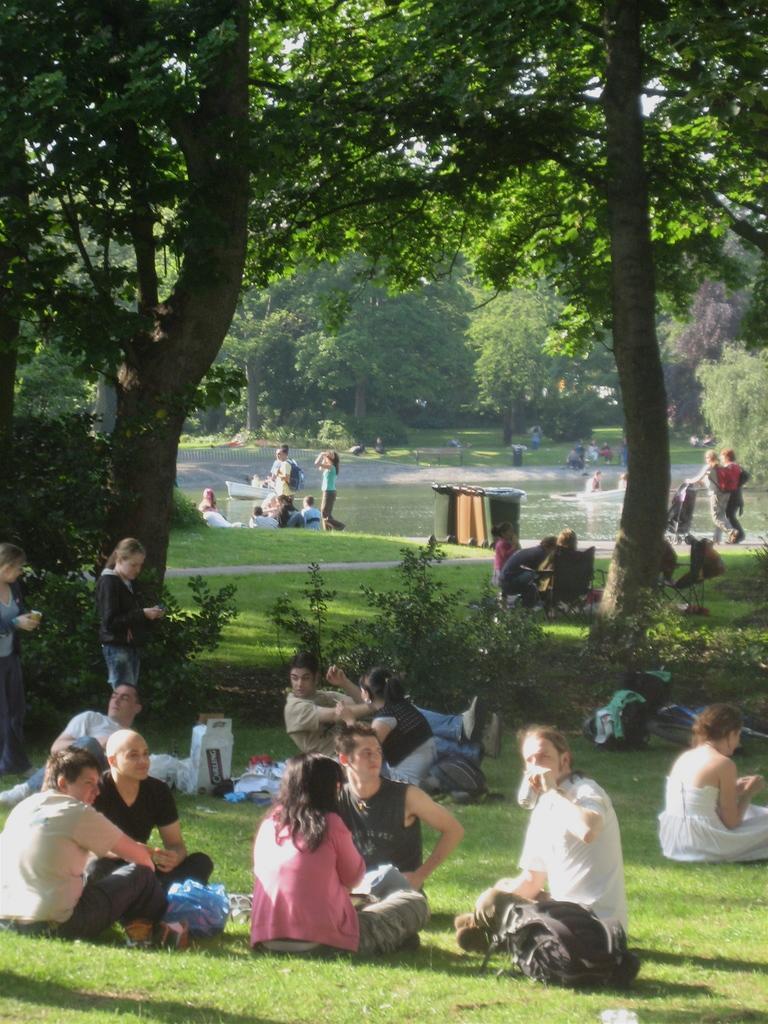Describe this image in one or two sentences. In this picture we can see people are in the water, around we can see some people are on the grass and we can see some trees. 